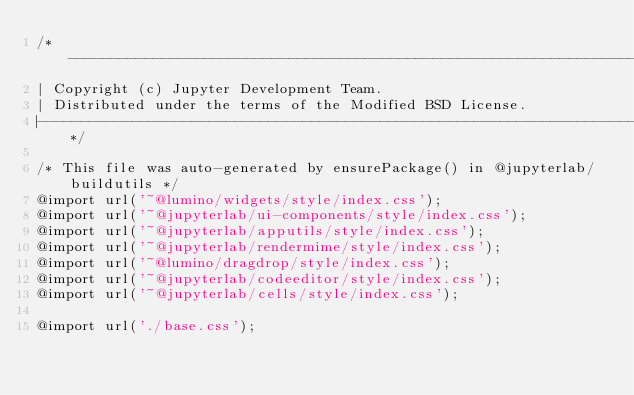<code> <loc_0><loc_0><loc_500><loc_500><_CSS_>/*-----------------------------------------------------------------------------
| Copyright (c) Jupyter Development Team.
| Distributed under the terms of the Modified BSD License.
|----------------------------------------------------------------------------*/

/* This file was auto-generated by ensurePackage() in @jupyterlab/buildutils */
@import url('~@lumino/widgets/style/index.css');
@import url('~@jupyterlab/ui-components/style/index.css');
@import url('~@jupyterlab/apputils/style/index.css');
@import url('~@jupyterlab/rendermime/style/index.css');
@import url('~@lumino/dragdrop/style/index.css');
@import url('~@jupyterlab/codeeditor/style/index.css');
@import url('~@jupyterlab/cells/style/index.css');

@import url('./base.css');
</code> 